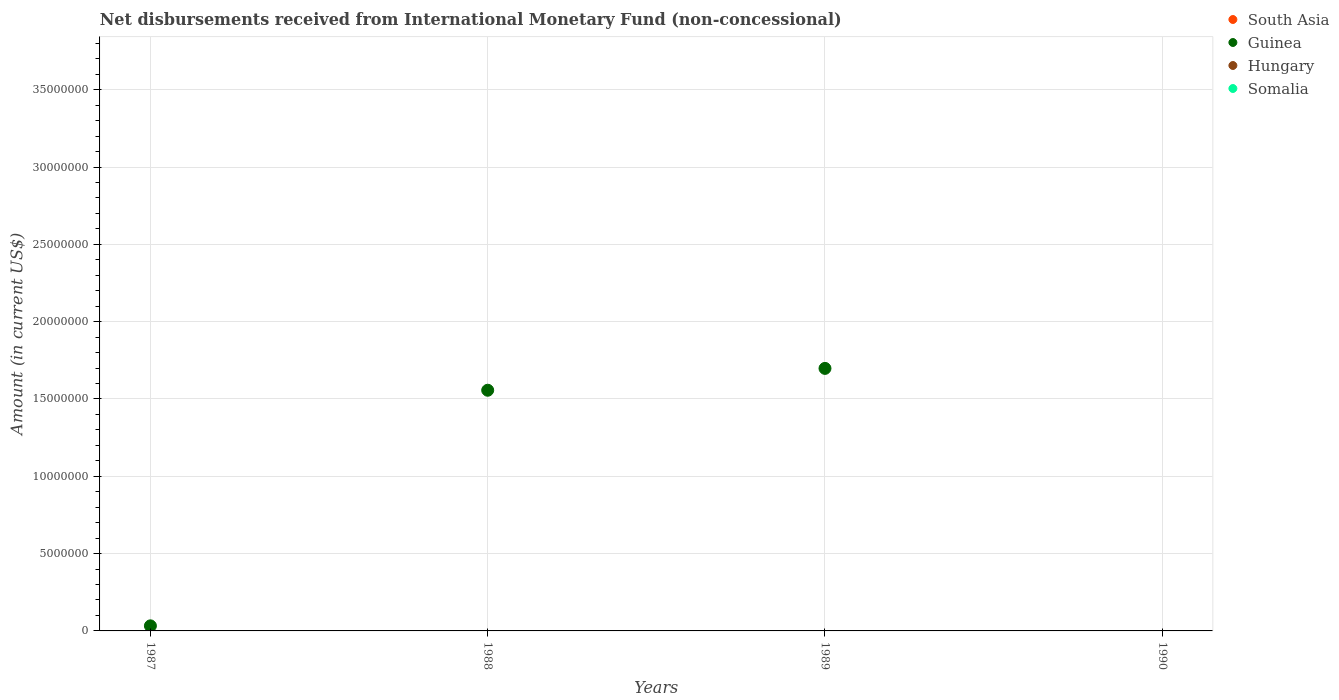How many different coloured dotlines are there?
Provide a short and direct response. 1. Is the number of dotlines equal to the number of legend labels?
Give a very brief answer. No. What is the amount of disbursements received from International Monetary Fund in Somalia in 1987?
Provide a short and direct response. 0. Across all years, what is the maximum amount of disbursements received from International Monetary Fund in Guinea?
Provide a short and direct response. 1.70e+07. In which year was the amount of disbursements received from International Monetary Fund in Guinea maximum?
Ensure brevity in your answer.  1989. What is the difference between the amount of disbursements received from International Monetary Fund in Guinea in 1987 and that in 1988?
Offer a terse response. -1.52e+07. What is the difference between the amount of disbursements received from International Monetary Fund in South Asia in 1990 and the amount of disbursements received from International Monetary Fund in Guinea in 1987?
Keep it short and to the point. -3.28e+05. What is the average amount of disbursements received from International Monetary Fund in Guinea per year?
Keep it short and to the point. 8.22e+06. In how many years, is the amount of disbursements received from International Monetary Fund in South Asia greater than 34000000 US$?
Offer a very short reply. 0. What is the ratio of the amount of disbursements received from International Monetary Fund in Guinea in 1988 to that in 1989?
Make the answer very short. 0.92. What is the difference between the highest and the second highest amount of disbursements received from International Monetary Fund in Guinea?
Provide a succinct answer. 1.41e+06. In how many years, is the amount of disbursements received from International Monetary Fund in Somalia greater than the average amount of disbursements received from International Monetary Fund in Somalia taken over all years?
Your answer should be compact. 0. Does the amount of disbursements received from International Monetary Fund in South Asia monotonically increase over the years?
Your answer should be very brief. No. Is the amount of disbursements received from International Monetary Fund in Hungary strictly less than the amount of disbursements received from International Monetary Fund in Somalia over the years?
Provide a short and direct response. Yes. How many dotlines are there?
Provide a succinct answer. 1. Where does the legend appear in the graph?
Your answer should be compact. Top right. How many legend labels are there?
Ensure brevity in your answer.  4. What is the title of the graph?
Offer a terse response. Net disbursements received from International Monetary Fund (non-concessional). What is the label or title of the Y-axis?
Your response must be concise. Amount (in current US$). What is the Amount (in current US$) of Guinea in 1987?
Give a very brief answer. 3.28e+05. What is the Amount (in current US$) of Somalia in 1987?
Provide a succinct answer. 0. What is the Amount (in current US$) in South Asia in 1988?
Keep it short and to the point. 0. What is the Amount (in current US$) in Guinea in 1988?
Your answer should be compact. 1.56e+07. What is the Amount (in current US$) of South Asia in 1989?
Ensure brevity in your answer.  0. What is the Amount (in current US$) of Guinea in 1989?
Provide a short and direct response. 1.70e+07. What is the Amount (in current US$) of Hungary in 1989?
Your answer should be very brief. 0. What is the Amount (in current US$) of Somalia in 1989?
Provide a short and direct response. 0. What is the Amount (in current US$) of South Asia in 1990?
Provide a short and direct response. 0. Across all years, what is the maximum Amount (in current US$) in Guinea?
Provide a short and direct response. 1.70e+07. Across all years, what is the minimum Amount (in current US$) in Guinea?
Your answer should be very brief. 0. What is the total Amount (in current US$) in South Asia in the graph?
Ensure brevity in your answer.  0. What is the total Amount (in current US$) in Guinea in the graph?
Provide a short and direct response. 3.29e+07. What is the total Amount (in current US$) in Hungary in the graph?
Provide a succinct answer. 0. What is the difference between the Amount (in current US$) in Guinea in 1987 and that in 1988?
Your answer should be compact. -1.52e+07. What is the difference between the Amount (in current US$) in Guinea in 1987 and that in 1989?
Offer a very short reply. -1.67e+07. What is the difference between the Amount (in current US$) in Guinea in 1988 and that in 1989?
Keep it short and to the point. -1.41e+06. What is the average Amount (in current US$) of South Asia per year?
Your answer should be very brief. 0. What is the average Amount (in current US$) in Guinea per year?
Offer a very short reply. 8.22e+06. What is the average Amount (in current US$) of Somalia per year?
Your answer should be compact. 0. What is the ratio of the Amount (in current US$) of Guinea in 1987 to that in 1988?
Make the answer very short. 0.02. What is the ratio of the Amount (in current US$) in Guinea in 1987 to that in 1989?
Keep it short and to the point. 0.02. What is the ratio of the Amount (in current US$) of Guinea in 1988 to that in 1989?
Make the answer very short. 0.92. What is the difference between the highest and the second highest Amount (in current US$) of Guinea?
Provide a short and direct response. 1.41e+06. What is the difference between the highest and the lowest Amount (in current US$) of Guinea?
Your answer should be compact. 1.70e+07. 